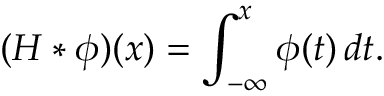Convert formula to latex. <formula><loc_0><loc_0><loc_500><loc_500>( H \ast \phi ) ( x ) = \int _ { - \infty } ^ { x } \phi ( t ) \, d t .</formula> 